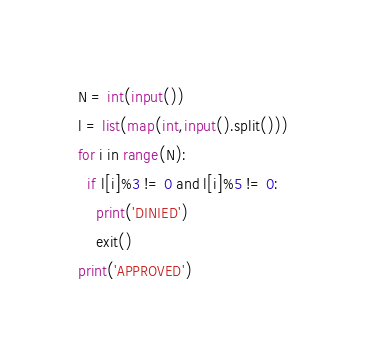<code> <loc_0><loc_0><loc_500><loc_500><_Python_>N = int(input())
l = list(map(int,input().split()))
for i in range(N):
  if l[i]%3 != 0 and l[i]%5 != 0:
    print('DINIED')
    exit()
print('APPROVED')</code> 